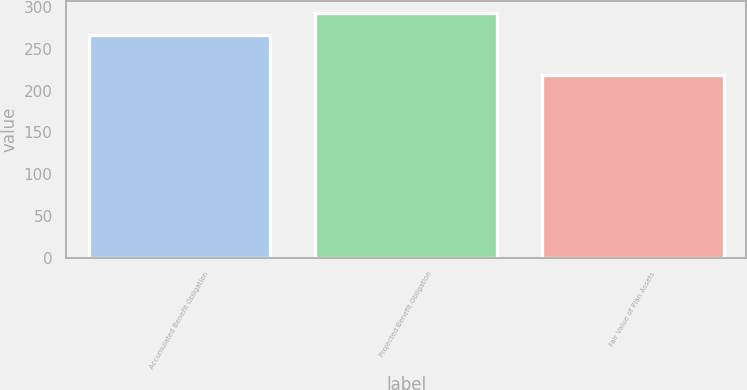<chart> <loc_0><loc_0><loc_500><loc_500><bar_chart><fcel>Accumulated Benefit Obligation<fcel>Projected Benefit Obligation<fcel>Fair Value of Plan Assets<nl><fcel>267<fcel>293<fcel>219<nl></chart> 